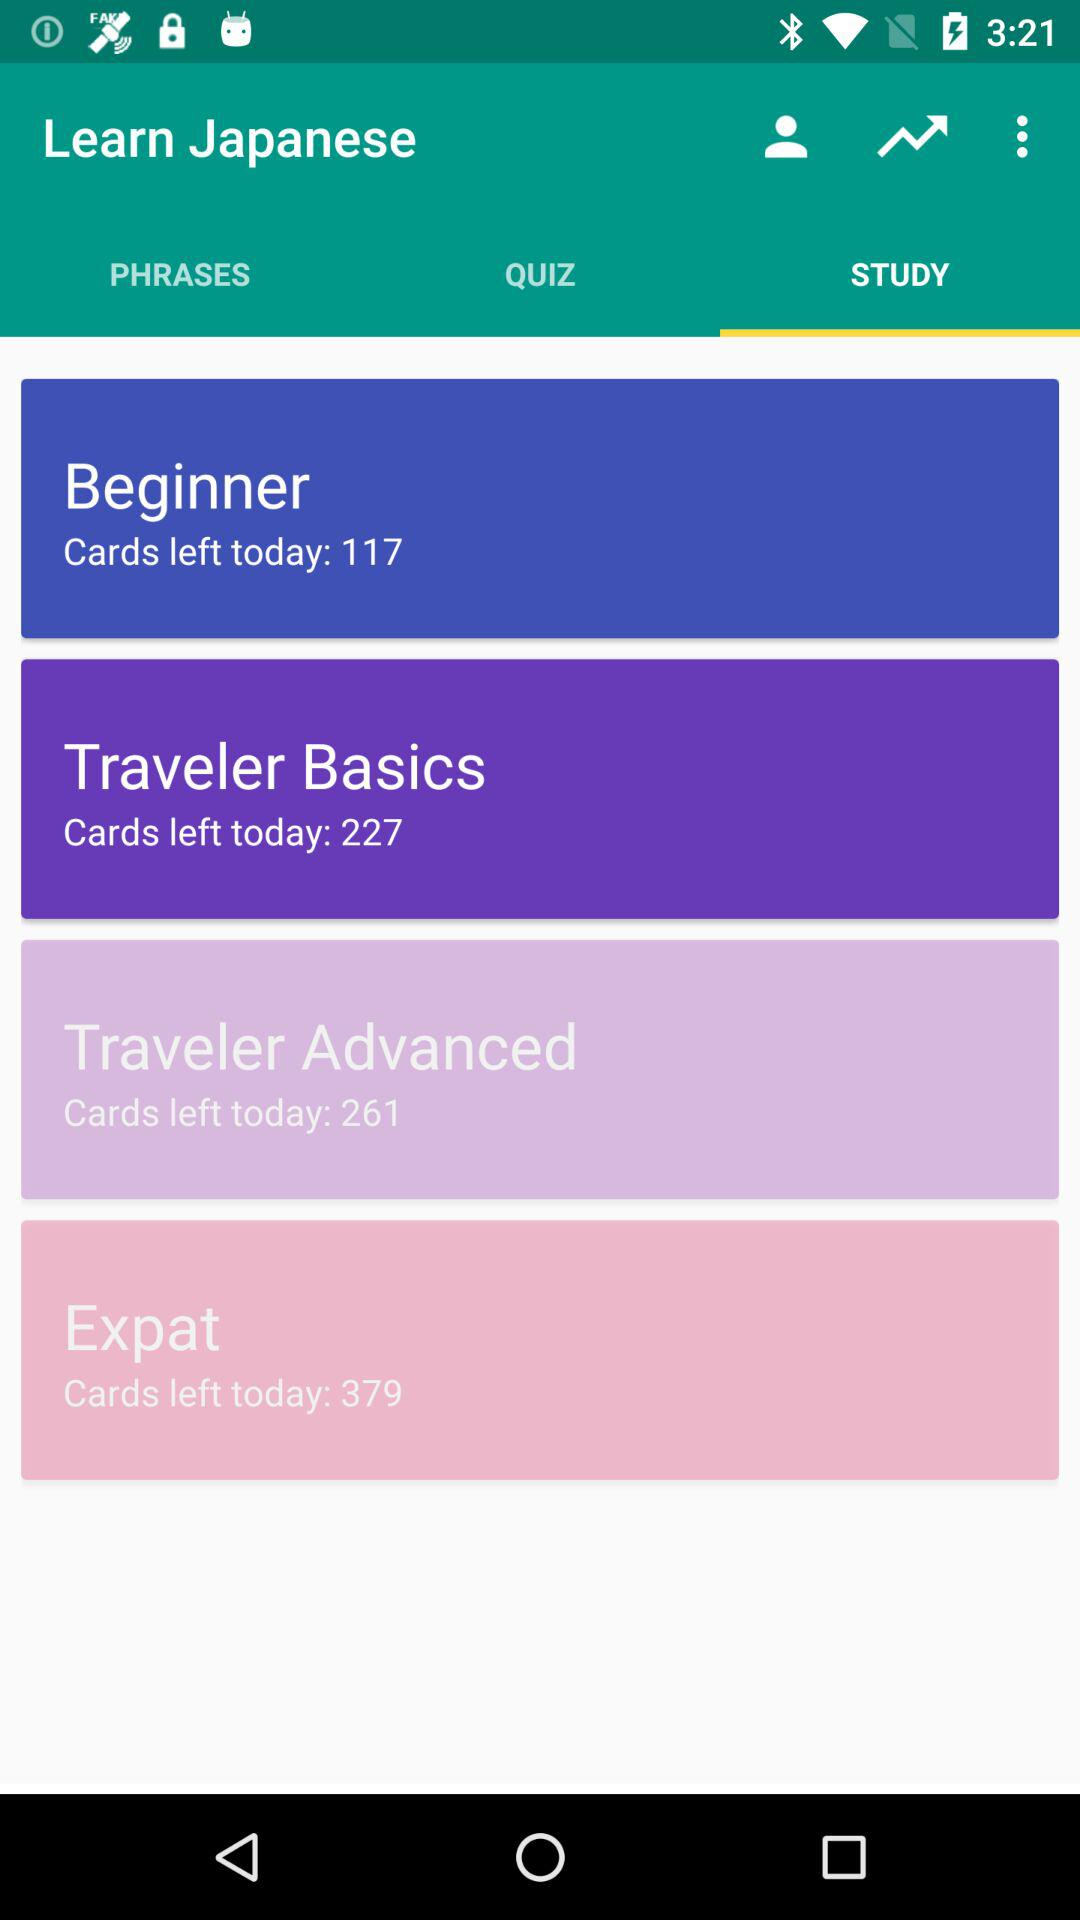How many cards are left in "Expat"? There are 379 cards left in "Expat". 